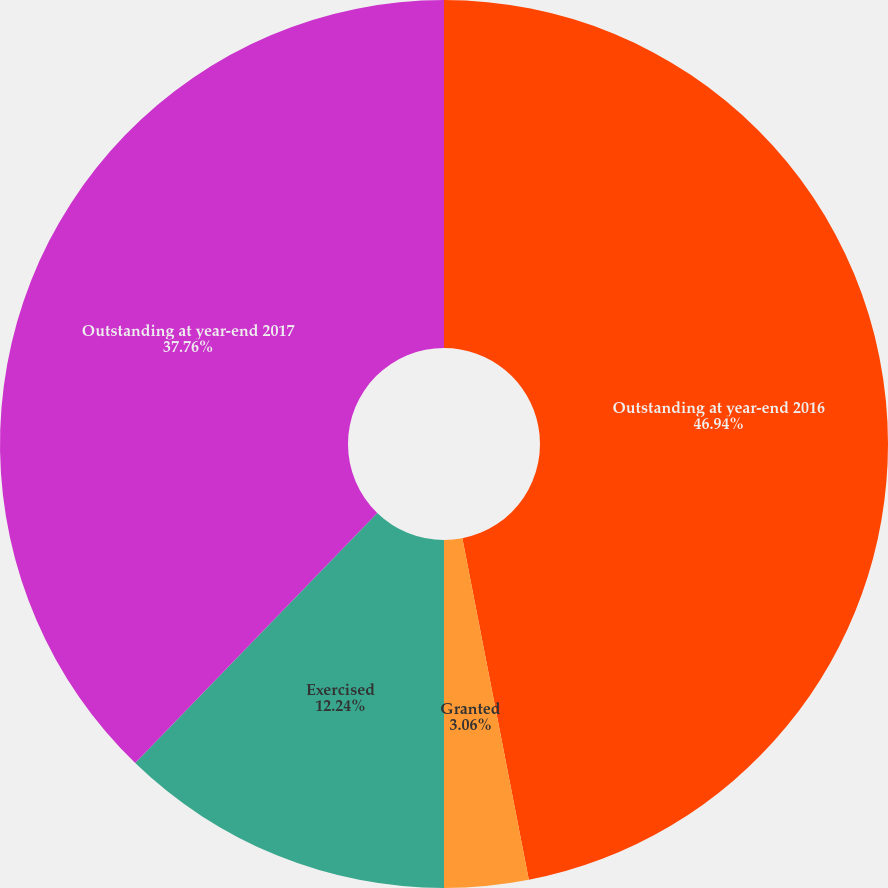Convert chart to OTSL. <chart><loc_0><loc_0><loc_500><loc_500><pie_chart><fcel>Outstanding at year-end 2016<fcel>Granted<fcel>Exercised<fcel>Outstanding at year-end 2017<nl><fcel>46.94%<fcel>3.06%<fcel>12.24%<fcel>37.76%<nl></chart> 